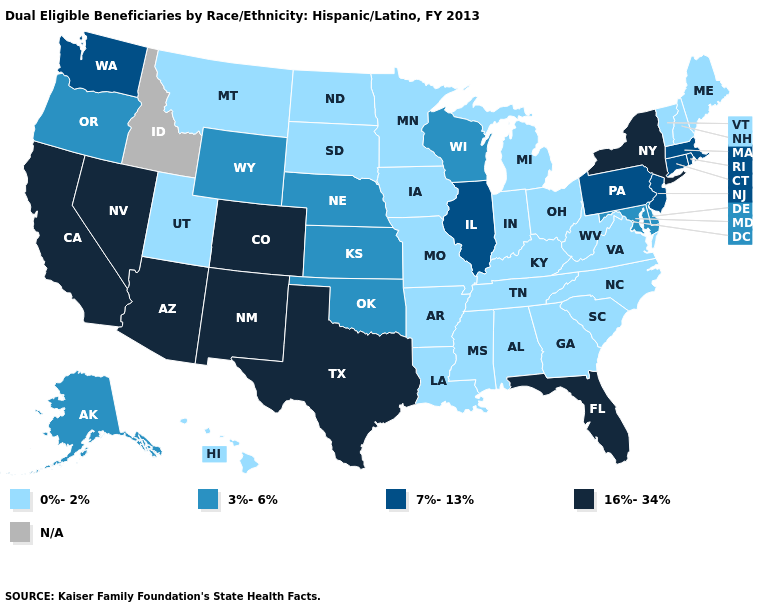Which states hav the highest value in the West?
Answer briefly. Arizona, California, Colorado, Nevada, New Mexico. What is the value of Minnesota?
Keep it brief. 0%-2%. Name the states that have a value in the range 0%-2%?
Concise answer only. Alabama, Arkansas, Georgia, Hawaii, Indiana, Iowa, Kentucky, Louisiana, Maine, Michigan, Minnesota, Mississippi, Missouri, Montana, New Hampshire, North Carolina, North Dakota, Ohio, South Carolina, South Dakota, Tennessee, Utah, Vermont, Virginia, West Virginia. Does Rhode Island have the lowest value in the Northeast?
Give a very brief answer. No. Does Vermont have the lowest value in the Northeast?
Keep it brief. Yes. What is the value of Wisconsin?
Short answer required. 3%-6%. Among the states that border Michigan , does Wisconsin have the highest value?
Short answer required. Yes. What is the value of Kentucky?
Concise answer only. 0%-2%. What is the value of Alaska?
Concise answer only. 3%-6%. Name the states that have a value in the range 0%-2%?
Answer briefly. Alabama, Arkansas, Georgia, Hawaii, Indiana, Iowa, Kentucky, Louisiana, Maine, Michigan, Minnesota, Mississippi, Missouri, Montana, New Hampshire, North Carolina, North Dakota, Ohio, South Carolina, South Dakota, Tennessee, Utah, Vermont, Virginia, West Virginia. Does Florida have the highest value in the USA?
Write a very short answer. Yes. Does New Mexico have the lowest value in the USA?
Keep it brief. No. Name the states that have a value in the range 7%-13%?
Write a very short answer. Connecticut, Illinois, Massachusetts, New Jersey, Pennsylvania, Rhode Island, Washington. Name the states that have a value in the range 7%-13%?
Answer briefly. Connecticut, Illinois, Massachusetts, New Jersey, Pennsylvania, Rhode Island, Washington. 